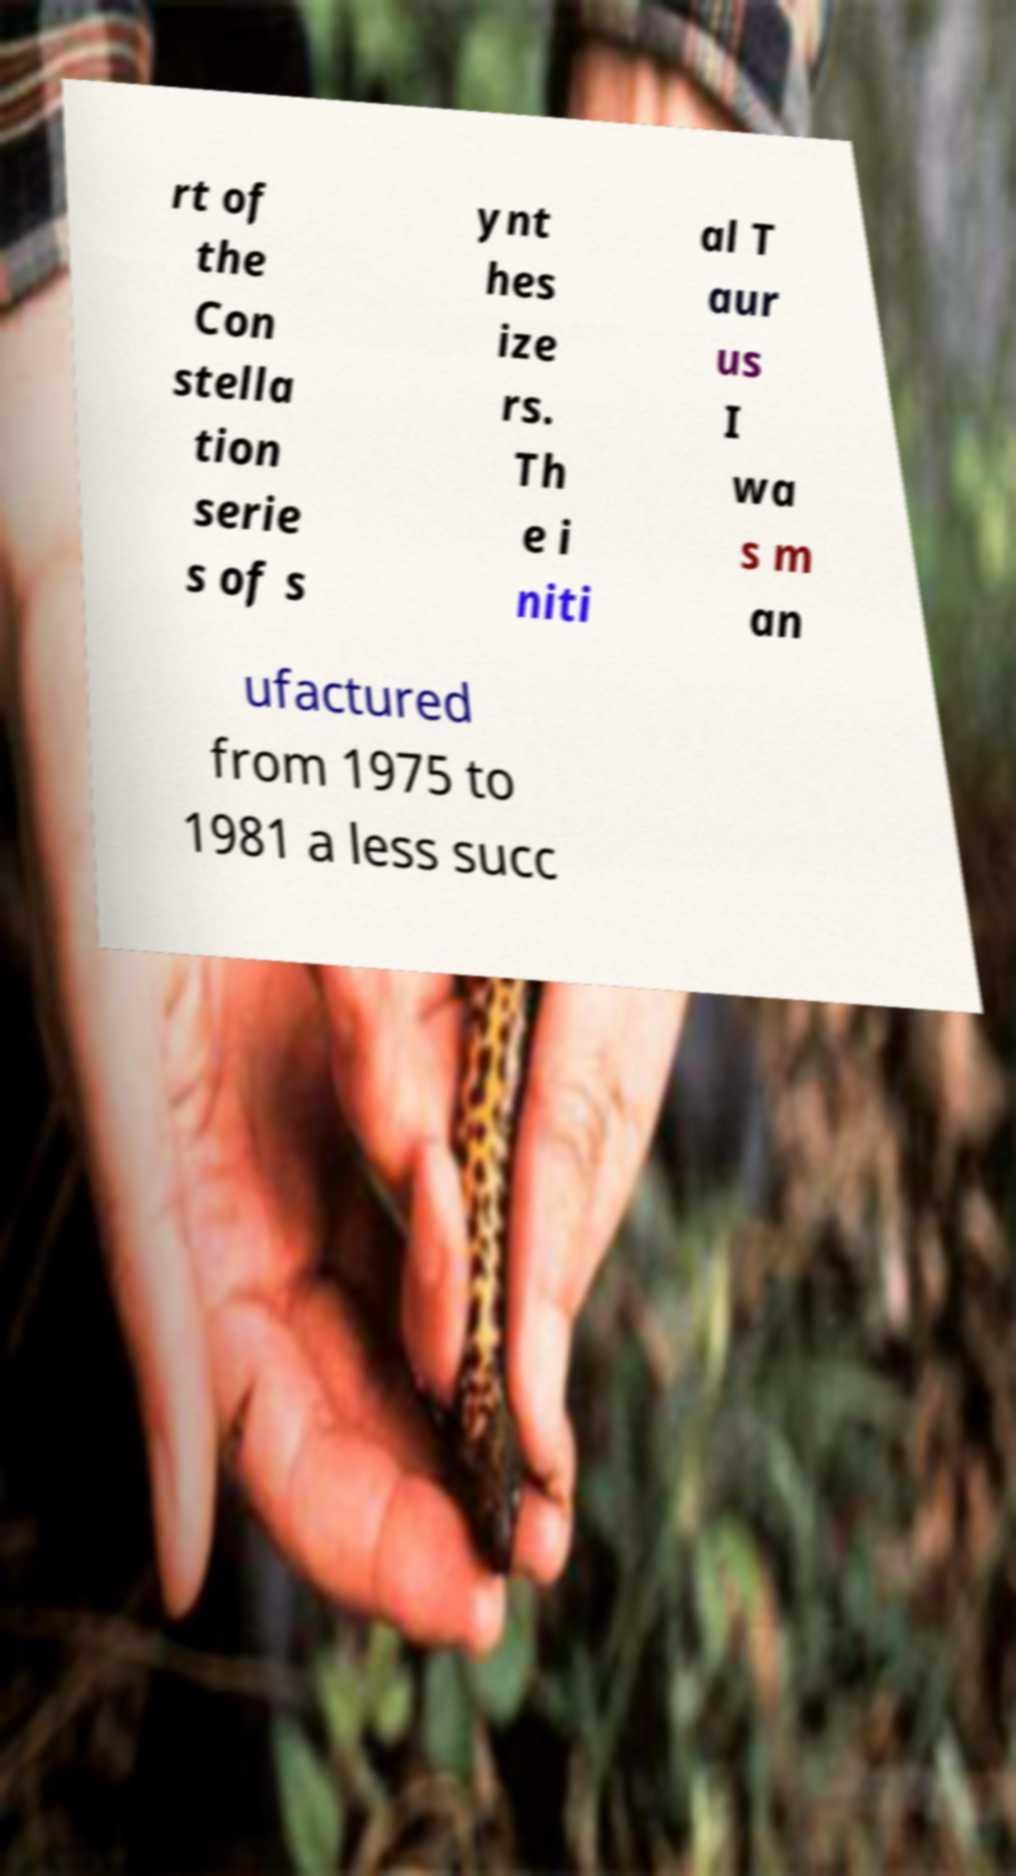For documentation purposes, I need the text within this image transcribed. Could you provide that? rt of the Con stella tion serie s of s ynt hes ize rs. Th e i niti al T aur us I wa s m an ufactured from 1975 to 1981 a less succ 